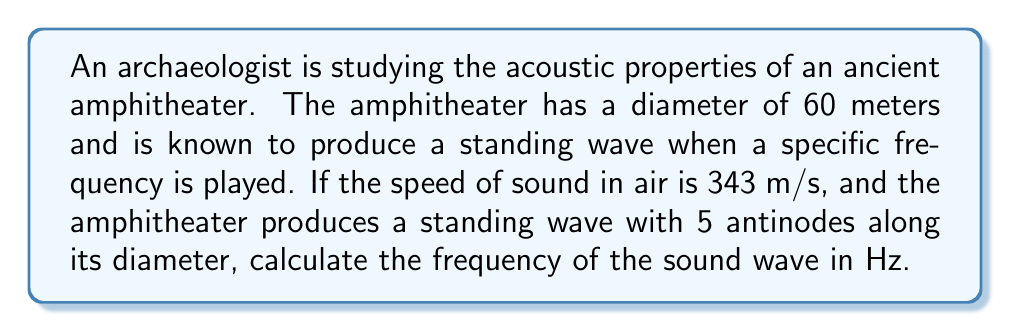Give your solution to this math problem. To solve this problem, we need to use the relationship between wavelength, frequency, and speed of sound, as well as the properties of standing waves.

1. First, let's recall the formula for the speed of sound:
   $$ v = f \lambda $$
   where $v$ is the speed of sound, $f$ is the frequency, and $\lambda$ is the wavelength.

2. In a standing wave, the distance between two consecutive antinodes is equal to half a wavelength. Since there are 5 antinodes along the diameter, there are 4 half-wavelengths fitting in the diameter.

3. We can express this mathematically:
   $$ 60 \text{ m} = 4 \cdot \frac{\lambda}{2} $$

4. Simplify to solve for $\lambda$:
   $$ \lambda = \frac{60 \text{ m}}{2} = 30 \text{ m} $$

5. Now that we know the wavelength and the speed of sound, we can use the formula from step 1 to find the frequency:
   $$ 343 \text{ m/s} = f \cdot 30 \text{ m} $$

6. Solve for $f$:
   $$ f = \frac{343 \text{ m/s}}{30 \text{ m}} = 11.43333... \text{ Hz} $$

7. Round to two decimal places:
   $$ f \approx 11.43 \text{ Hz} $$
Answer: The frequency of the sound wave in the ancient amphitheater is approximately 11.43 Hz. 